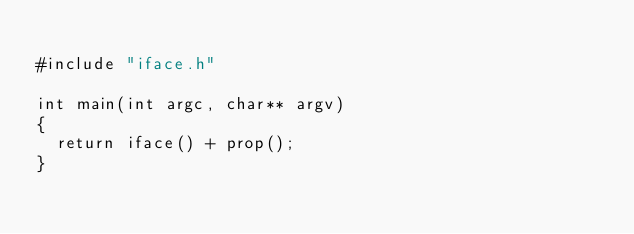Convert code to text. <code><loc_0><loc_0><loc_500><loc_500><_C++_>
#include "iface.h"

int main(int argc, char** argv)
{
  return iface() + prop();
}
</code> 